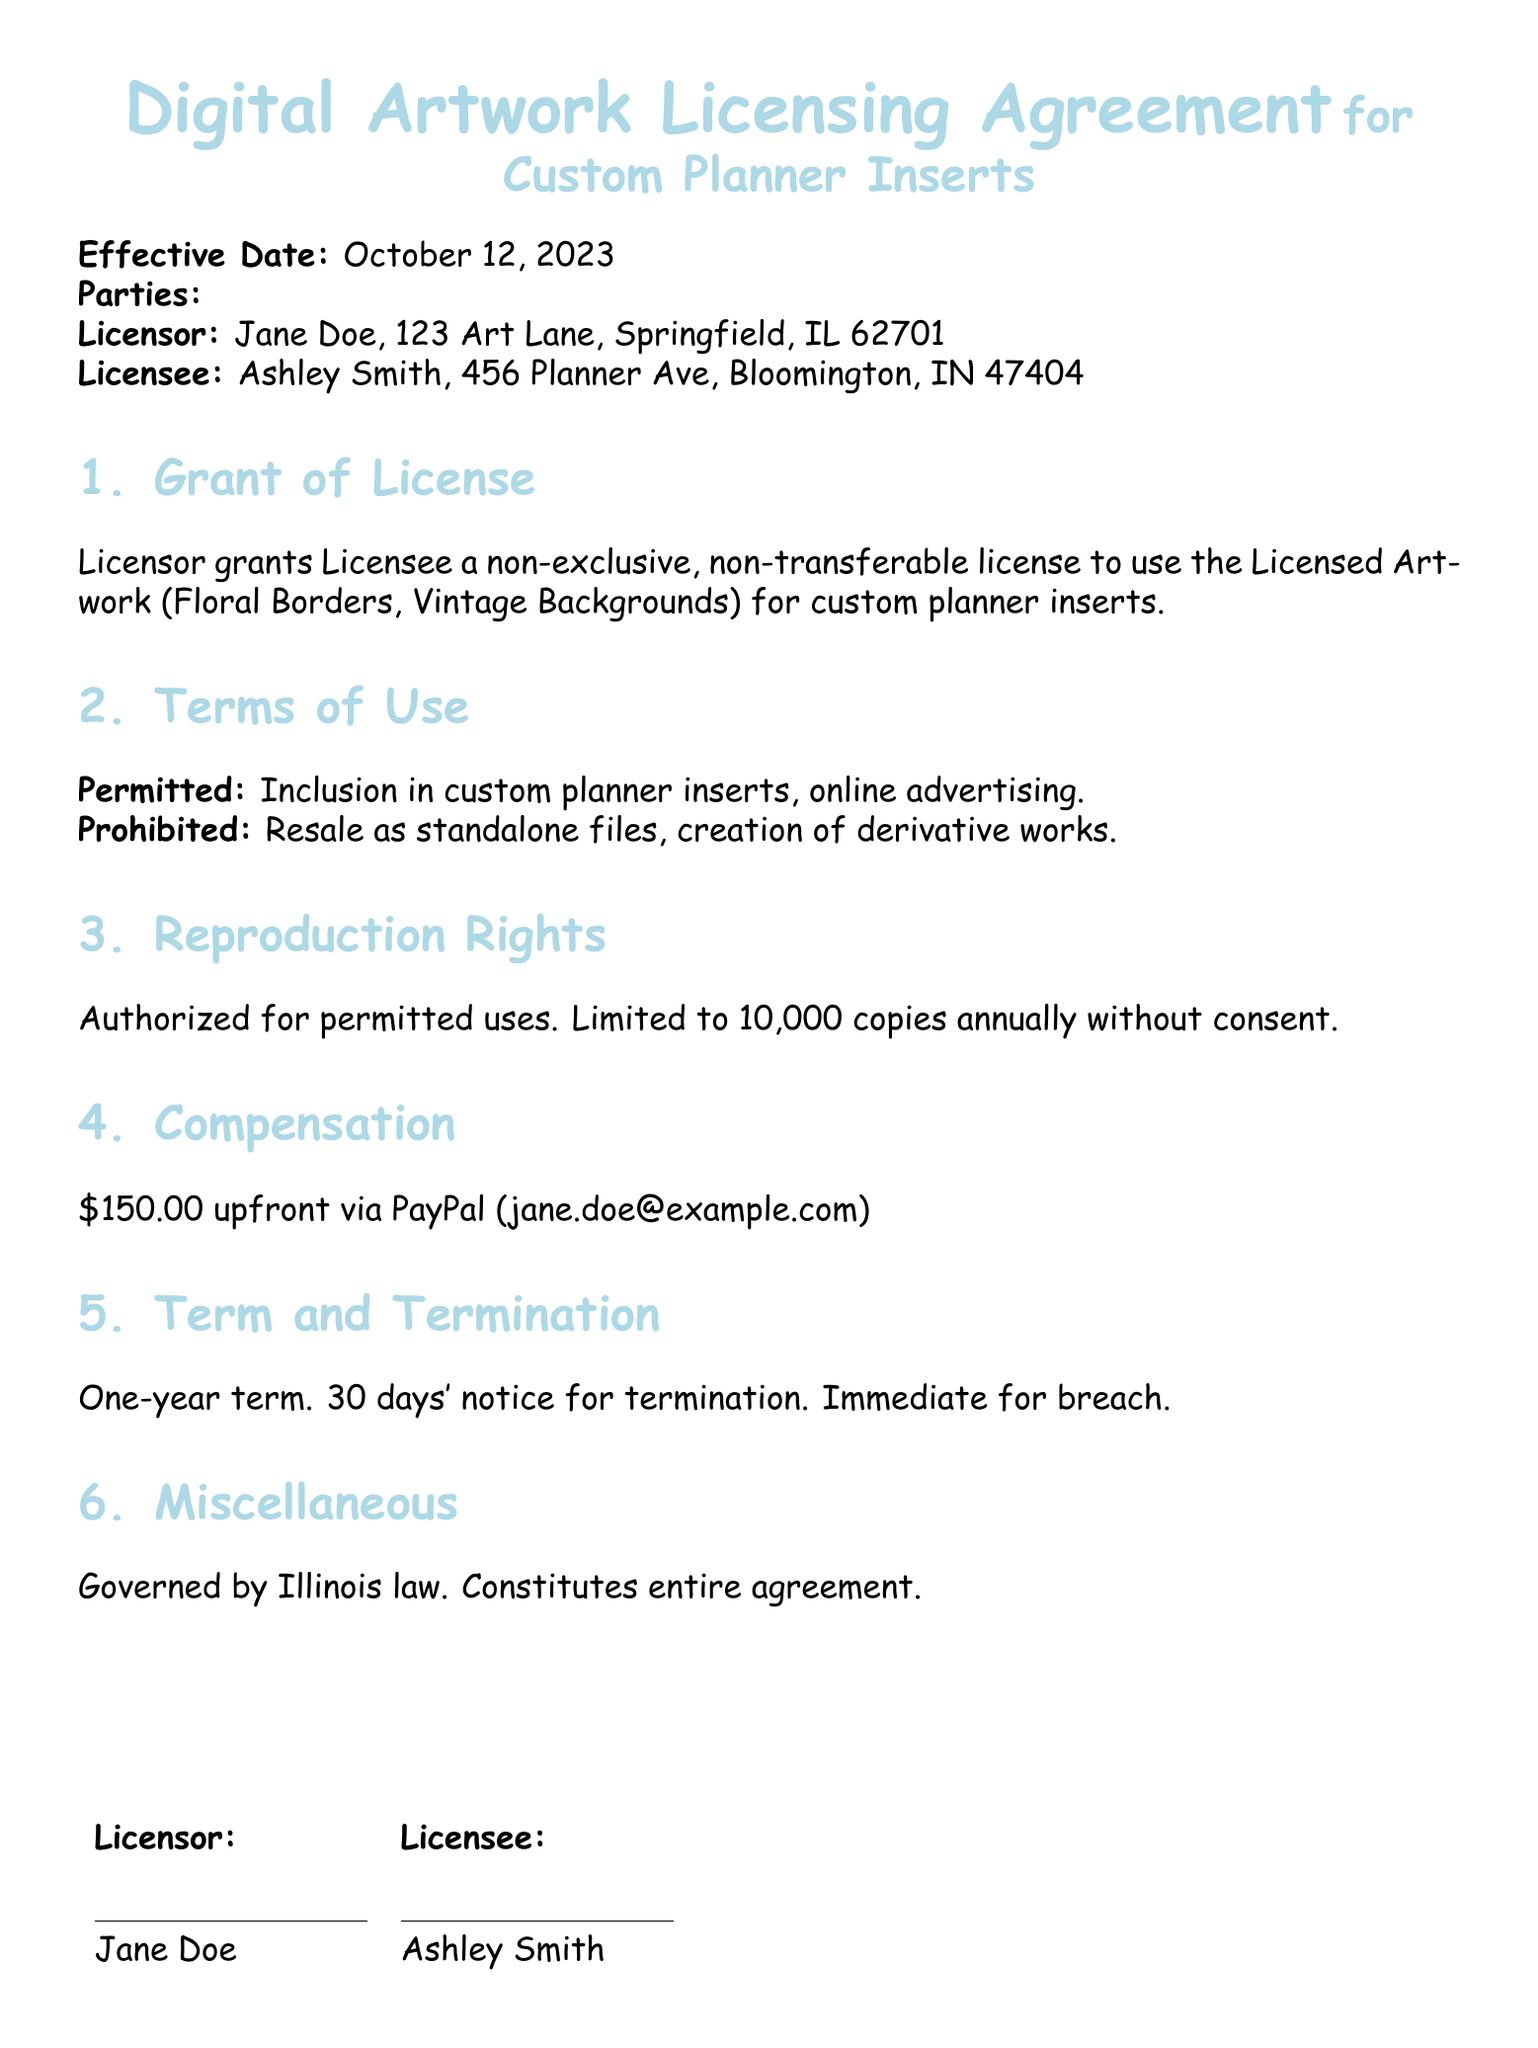What is the effective date of the agreement? The effective date is stated at the beginning of the document and is October 12, 2023.
Answer: October 12, 2023 Who is the Licensor? The Licensor's name appears in the parties section of the document.
Answer: Jane Doe What is the licensee's address? The Licensee's address is listed under the parties section.
Answer: 456 Planner Ave, Bloomington, IN 47404 How much is the compensation for the license? The compensation amount is specified in the compensation section of the document.
Answer: $150.00 How many copies can the Licensee reproduce annually without consent? This information is specified in the reproduction rights section.
Answer: 10,000 copies What types of use are permitted under this agreement? The permitted uses are listed in the terms of use section of the document.
Answer: Inclusion in custom planner inserts, online advertising What type of license is granted to the Licensee? This information is provided in the grant of license section.
Answer: Non-exclusive, non-transferable What law governs the agreement? The governing law is specified in the miscellaneous section of the document.
Answer: Illinois law 